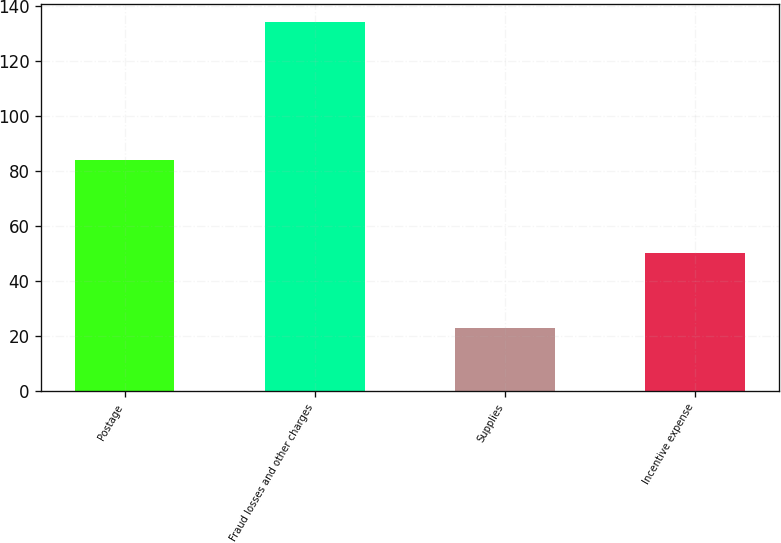<chart> <loc_0><loc_0><loc_500><loc_500><bar_chart><fcel>Postage<fcel>Fraud losses and other charges<fcel>Supplies<fcel>Incentive expense<nl><fcel>84<fcel>134<fcel>23<fcel>50<nl></chart> 